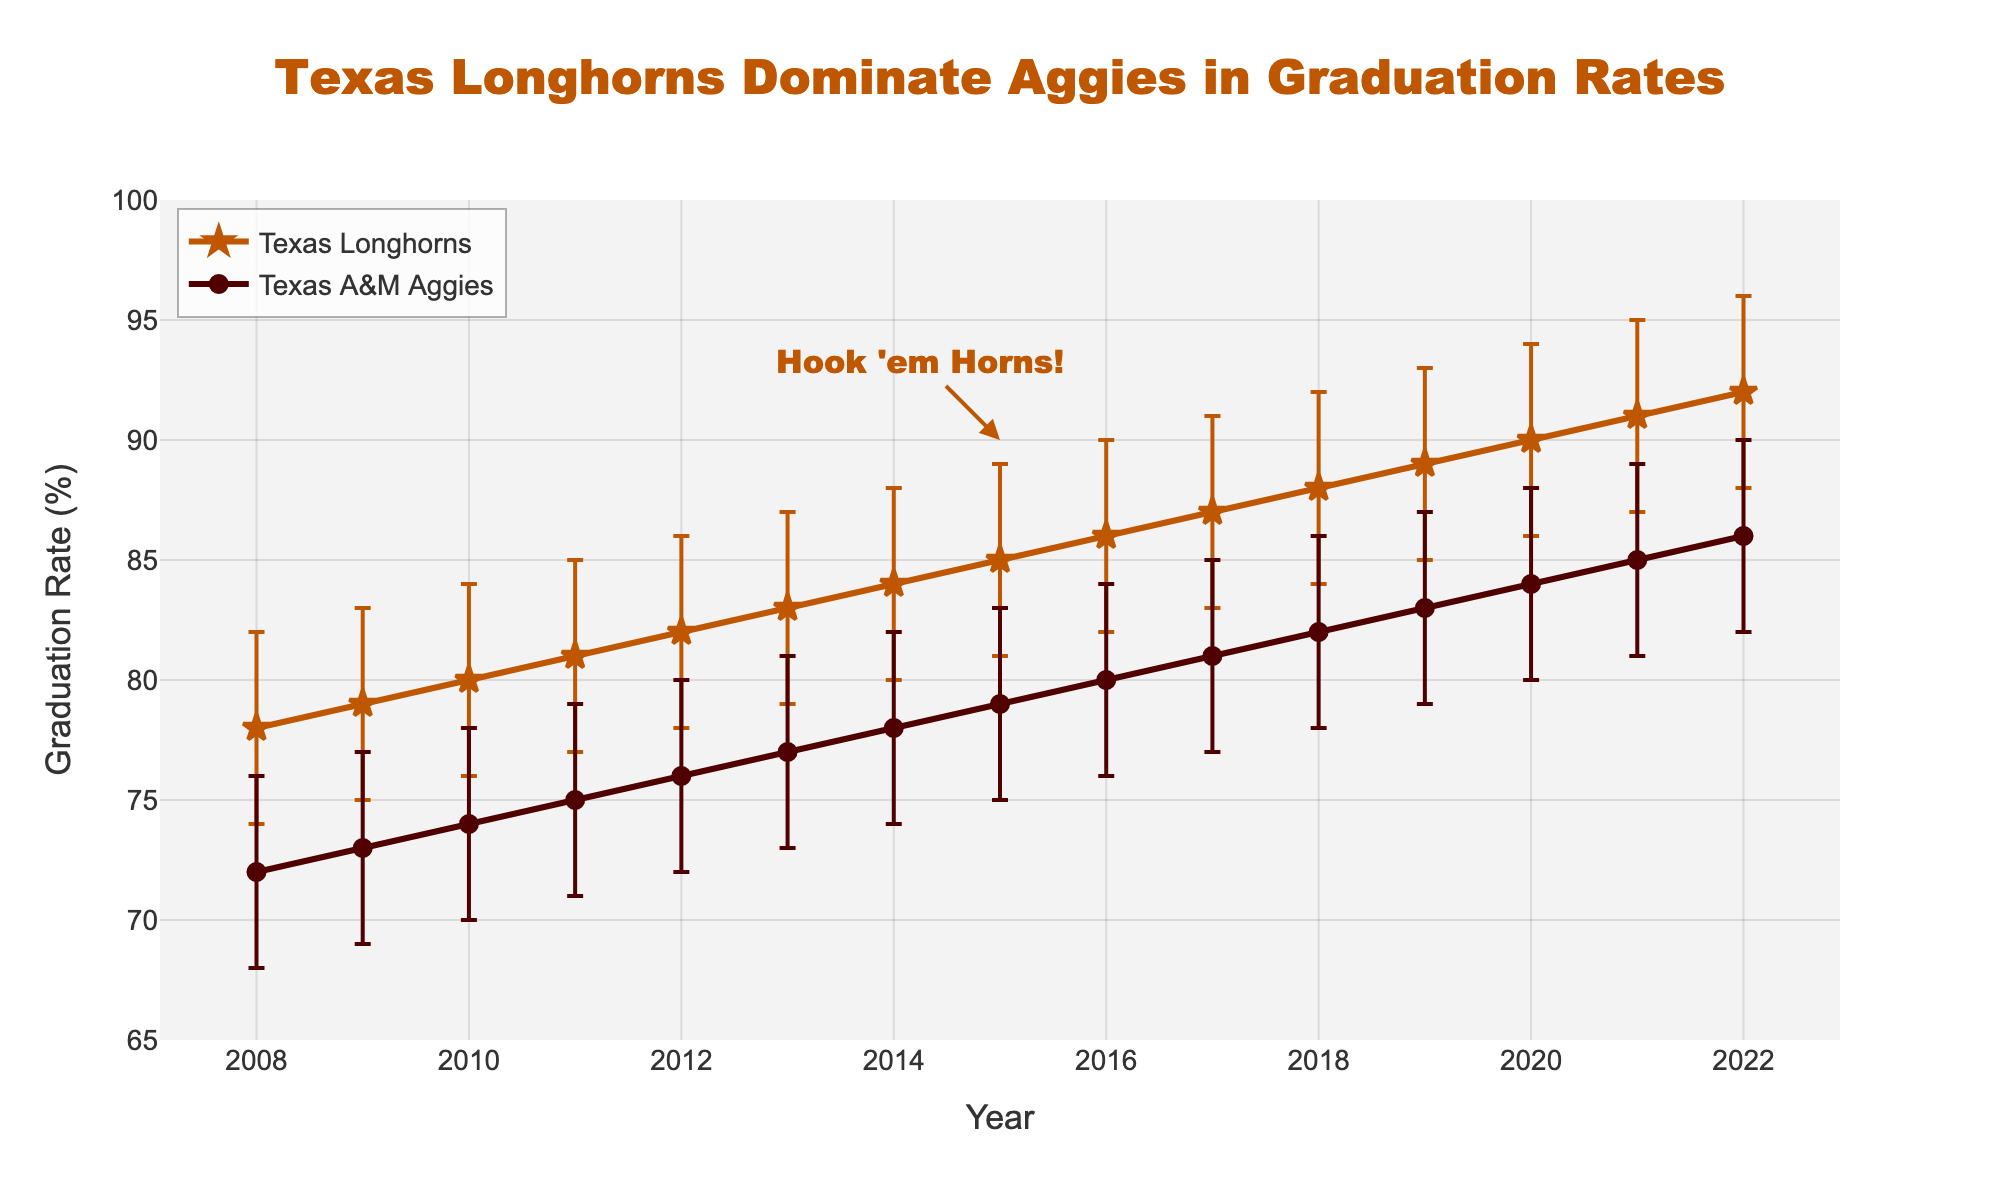What is the title of the plot? The plot title is located at the top of the figure, styled prominently in large, orange text.
Answer: Texas Longhorns Dominate Aggies in Graduation Rates What is the graduation rate for Texas Longhorns in 2012? Look at the point labeled "2012" on the x-axis and follow it up to the intercept with the "Texas Longhorns" line.
Answer: 82% In which year did Texas A&M Aggies first reach an 80% graduation rate? Follow the data points of Texas A&M Aggies until you reach the first point where the rate meets or exceeds 80%.
Answer: 2016 Which school has consistently higher graduation rates over the period shown? Compare the trend lines for both schools throughout the 15 years. The Texas Longhorns line generally stays above Texas A&M Aggies line.
Answer: Texas Longhorns How does the 95% confidence interval for the Texas Longhorns in 2020 compare to that in 2008? Compare the length of the error bars for both years for Texas Longhorns by examining the difference between the upper and lower bounds.
Answer: The 2020 confidence interval is narrower (86-94) compared to the 2008 (74-82) What is the average graduation rate for Texas A&M Aggies between 2015 to 2020? Add the graduation rates for the years 2015, 2016, 2017, 2018, 2019, and 2020 and divide by the number of years.
Answer: (79+80+81+82+83+84)/6 = 81.5% What is the difference in graduation rates between Texas Longhorns and Texas A&M Aggies in 2022? Subtract Texas A&M Aggies' graduation rate from Texas Longhorns' graduation rate for the year 2022.
Answer: 92 - 86 = 6% Which year did the Texas Longhorns have a graduation rate of 87%? Locate the data point where the y-value of the Texas Longhorns line is 87% and read the corresponding x-axis label.
Answer: 2017 Do the error bars overlap more in early years or later years? Visually inspect the proximity and overlap of the error bars between both schools in the initial years compared to the final years.
Answer: Early years What is the overall trend in graduation rates for both schools over the 15-year period? Examine the general direction in which both lines move from 2008 to 2022.
Answer: Increasing 